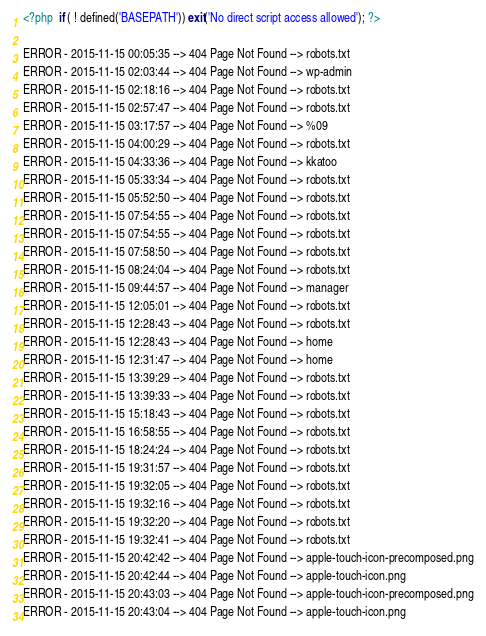<code> <loc_0><loc_0><loc_500><loc_500><_PHP_><?php  if ( ! defined('BASEPATH')) exit('No direct script access allowed'); ?>

ERROR - 2015-11-15 00:05:35 --> 404 Page Not Found --> robots.txt
ERROR - 2015-11-15 02:03:44 --> 404 Page Not Found --> wp-admin
ERROR - 2015-11-15 02:18:16 --> 404 Page Not Found --> robots.txt
ERROR - 2015-11-15 02:57:47 --> 404 Page Not Found --> robots.txt
ERROR - 2015-11-15 03:17:57 --> 404 Page Not Found --> %09
ERROR - 2015-11-15 04:00:29 --> 404 Page Not Found --> robots.txt
ERROR - 2015-11-15 04:33:36 --> 404 Page Not Found --> kkatoo
ERROR - 2015-11-15 05:33:34 --> 404 Page Not Found --> robots.txt
ERROR - 2015-11-15 05:52:50 --> 404 Page Not Found --> robots.txt
ERROR - 2015-11-15 07:54:55 --> 404 Page Not Found --> robots.txt
ERROR - 2015-11-15 07:54:55 --> 404 Page Not Found --> robots.txt
ERROR - 2015-11-15 07:58:50 --> 404 Page Not Found --> robots.txt
ERROR - 2015-11-15 08:24:04 --> 404 Page Not Found --> robots.txt
ERROR - 2015-11-15 09:44:57 --> 404 Page Not Found --> manager
ERROR - 2015-11-15 12:05:01 --> 404 Page Not Found --> robots.txt
ERROR - 2015-11-15 12:28:43 --> 404 Page Not Found --> robots.txt
ERROR - 2015-11-15 12:28:43 --> 404 Page Not Found --> home
ERROR - 2015-11-15 12:31:47 --> 404 Page Not Found --> home
ERROR - 2015-11-15 13:39:29 --> 404 Page Not Found --> robots.txt
ERROR - 2015-11-15 13:39:33 --> 404 Page Not Found --> robots.txt
ERROR - 2015-11-15 15:18:43 --> 404 Page Not Found --> robots.txt
ERROR - 2015-11-15 16:58:55 --> 404 Page Not Found --> robots.txt
ERROR - 2015-11-15 18:24:24 --> 404 Page Not Found --> robots.txt
ERROR - 2015-11-15 19:31:57 --> 404 Page Not Found --> robots.txt
ERROR - 2015-11-15 19:32:05 --> 404 Page Not Found --> robots.txt
ERROR - 2015-11-15 19:32:16 --> 404 Page Not Found --> robots.txt
ERROR - 2015-11-15 19:32:20 --> 404 Page Not Found --> robots.txt
ERROR - 2015-11-15 19:32:41 --> 404 Page Not Found --> robots.txt
ERROR - 2015-11-15 20:42:42 --> 404 Page Not Found --> apple-touch-icon-precomposed.png
ERROR - 2015-11-15 20:42:44 --> 404 Page Not Found --> apple-touch-icon.png
ERROR - 2015-11-15 20:43:03 --> 404 Page Not Found --> apple-touch-icon-precomposed.png
ERROR - 2015-11-15 20:43:04 --> 404 Page Not Found --> apple-touch-icon.png
</code> 